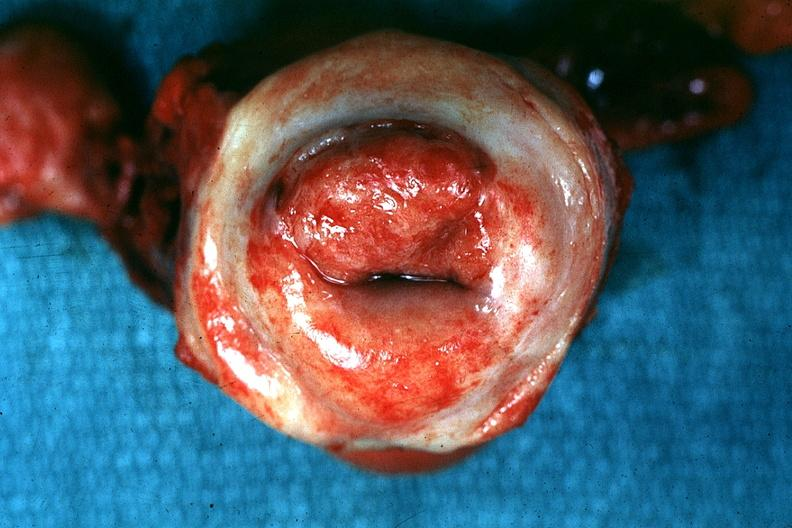s uterus present?
Answer the question using a single word or phrase. Yes 